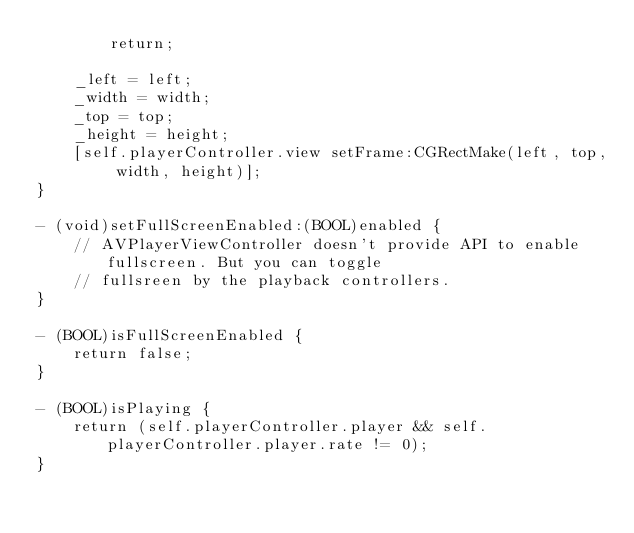Convert code to text. <code><loc_0><loc_0><loc_500><loc_500><_ObjectiveC_>        return;

    _left = left;
    _width = width;
    _top = top;
    _height = height;
    [self.playerController.view setFrame:CGRectMake(left, top, width, height)];
}

- (void)setFullScreenEnabled:(BOOL)enabled {
    // AVPlayerViewController doesn't provide API to enable fullscreen. But you can toggle
    // fullsreen by the playback controllers.
}

- (BOOL)isFullScreenEnabled {
    return false;
}

- (BOOL)isPlaying {
    return (self.playerController.player && self.playerController.player.rate != 0);
}
</code> 